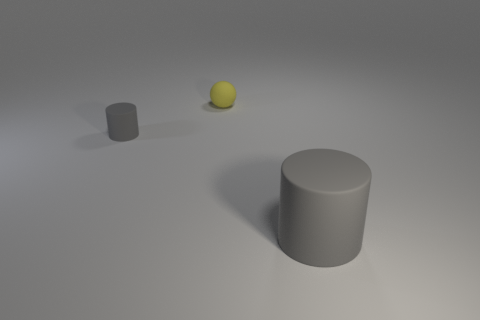Add 2 big gray matte cylinders. How many objects exist? 5 Subtract 0 green cylinders. How many objects are left? 3 Subtract all cylinders. How many objects are left? 1 Subtract all small gray matte cylinders. Subtract all tiny brown things. How many objects are left? 2 Add 3 small gray matte things. How many small gray matte things are left? 4 Add 2 yellow matte things. How many yellow matte things exist? 3 